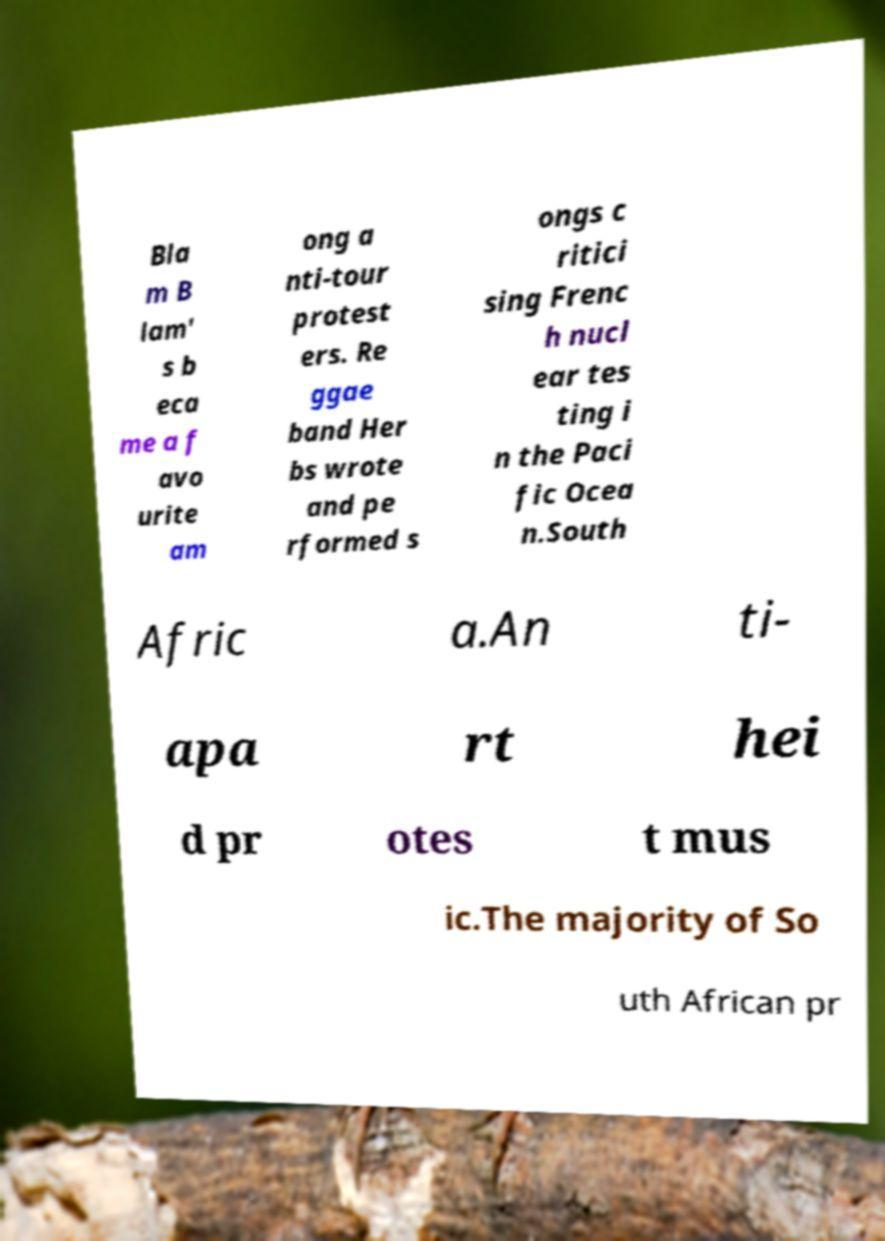Please read and relay the text visible in this image. What does it say? Bla m B lam' s b eca me a f avo urite am ong a nti-tour protest ers. Re ggae band Her bs wrote and pe rformed s ongs c ritici sing Frenc h nucl ear tes ting i n the Paci fic Ocea n.South Afric a.An ti- apa rt hei d pr otes t mus ic.The majority of So uth African pr 